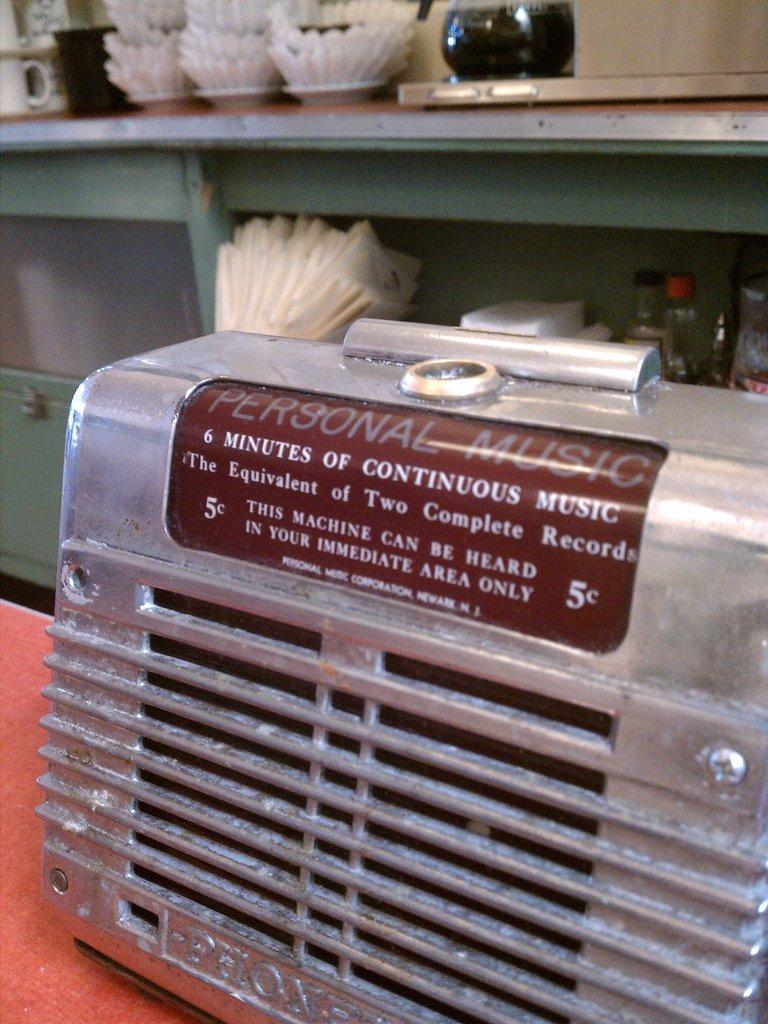What type of material is the main object in the image made of? The main object in the image is made of metal. What is visible on the metal object? Something is written on the metal object. What can be seen in the background of the image? There are cups, bottles, and other objects in the background of the image. How many cats are sitting on the metal object in the image? There are no cats present in the image. What type of light source is illuminating the metal object in the image? There is no specific light source mentioned or visible in the image. 